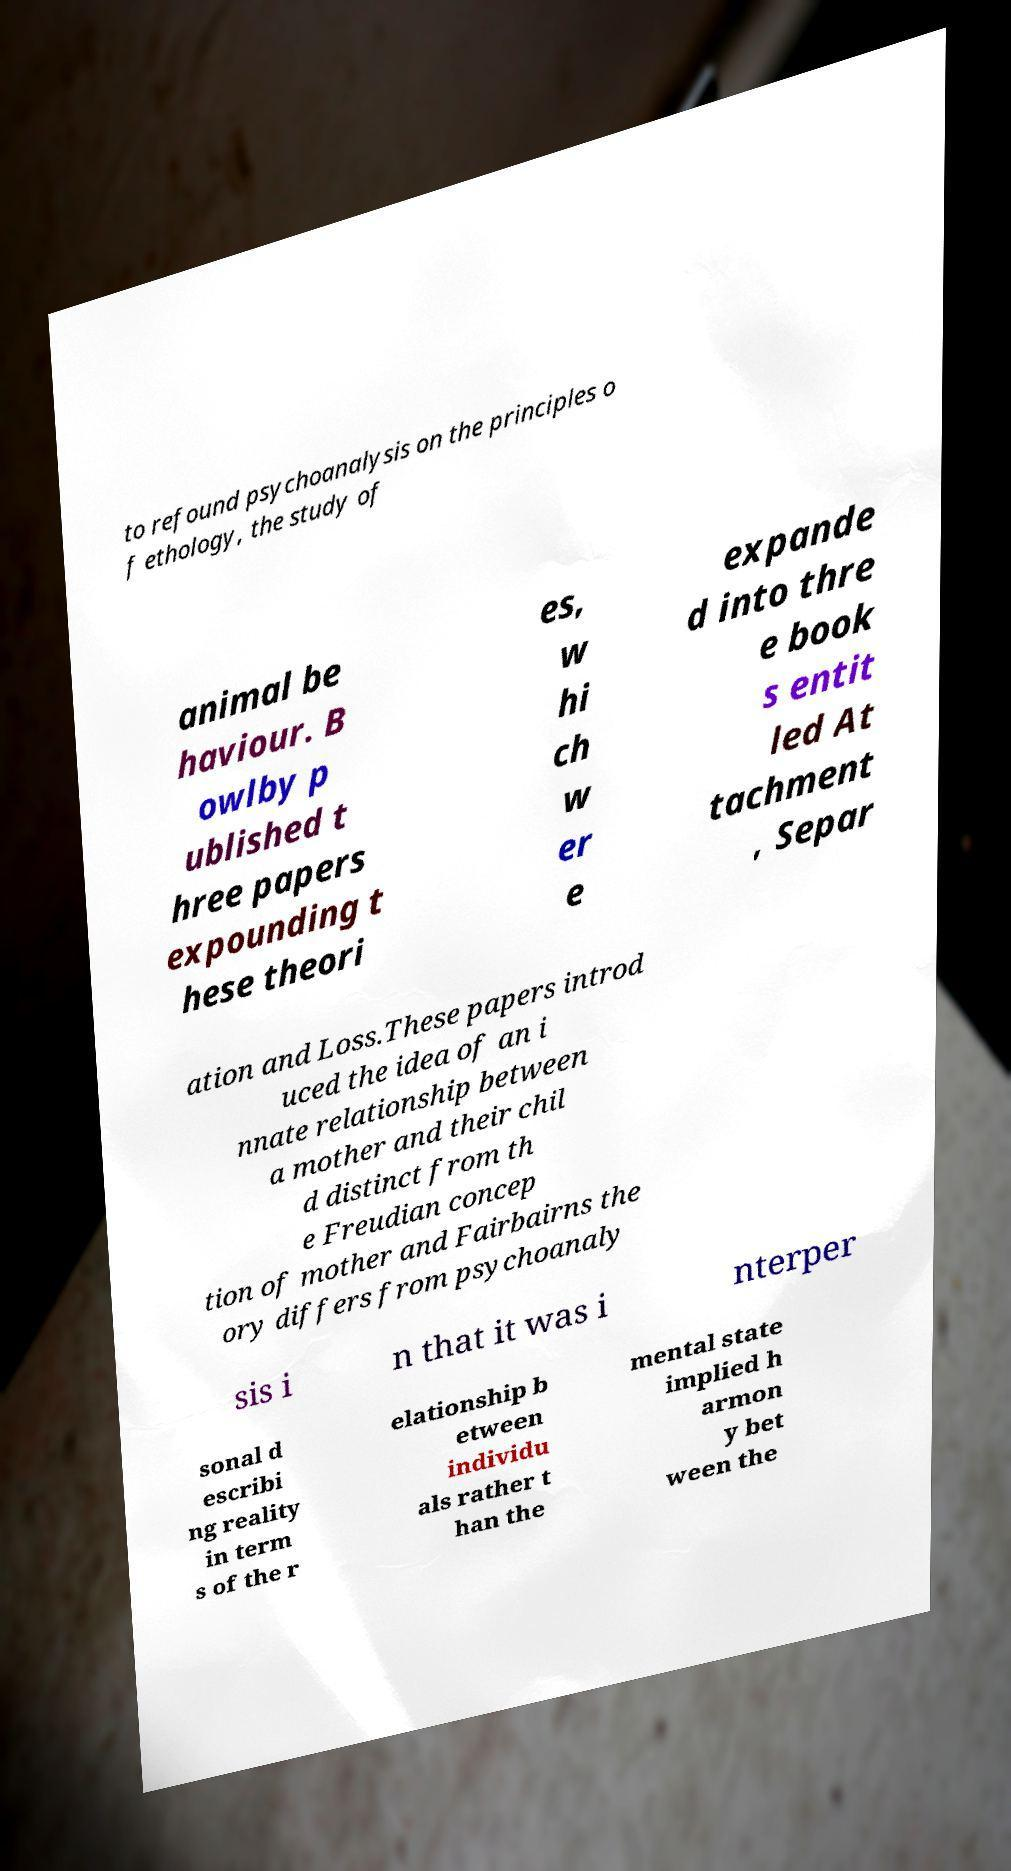Please read and relay the text visible in this image. What does it say? to refound psychoanalysis on the principles o f ethology, the study of animal be haviour. B owlby p ublished t hree papers expounding t hese theori es, w hi ch w er e expande d into thre e book s entit led At tachment , Separ ation and Loss.These papers introd uced the idea of an i nnate relationship between a mother and their chil d distinct from th e Freudian concep tion of mother and Fairbairns the ory differs from psychoanaly sis i n that it was i nterper sonal d escribi ng reality in term s of the r elationship b etween individu als rather t han the mental state implied h armon y bet ween the 